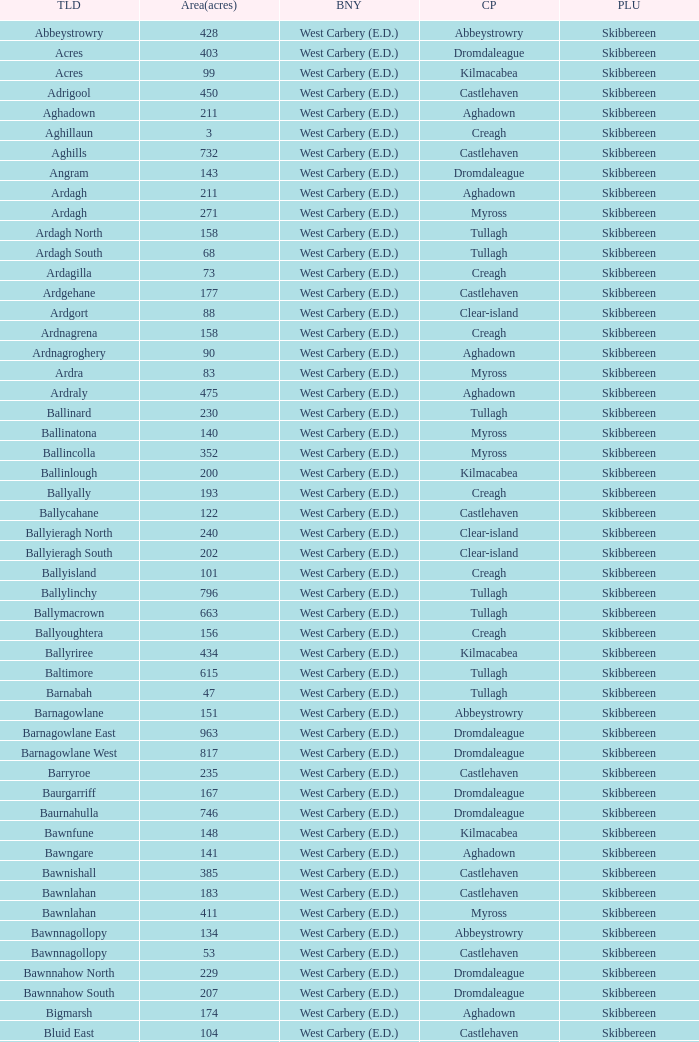What is the greatest area when the Poor Law Union is Skibbereen and the Civil Parish is Tullagh? 796.0. 